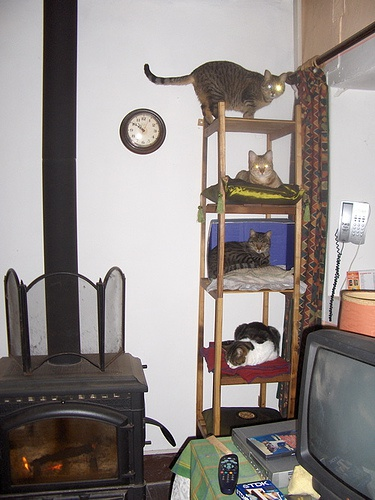Describe the objects in this image and their specific colors. I can see tv in gray and black tones, cat in gray and black tones, cat in gray, black, lightgray, and darkgray tones, cat in gray and black tones, and clock in gray, lightgray, and black tones in this image. 